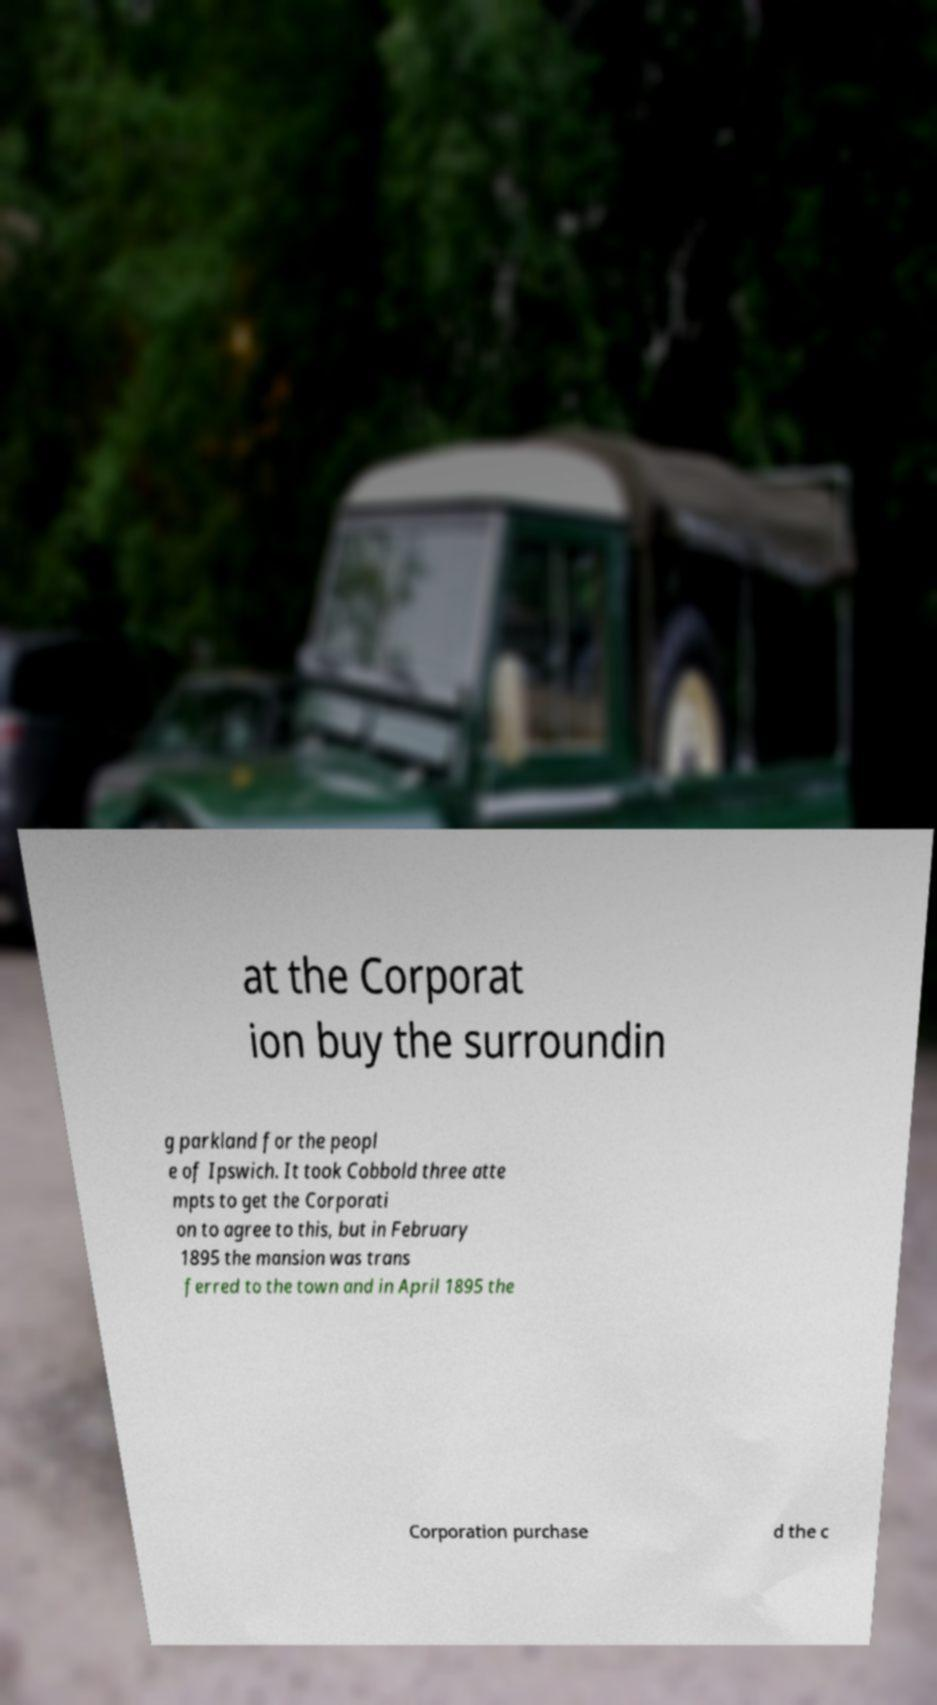Can you read and provide the text displayed in the image?This photo seems to have some interesting text. Can you extract and type it out for me? at the Corporat ion buy the surroundin g parkland for the peopl e of Ipswich. It took Cobbold three atte mpts to get the Corporati on to agree to this, but in February 1895 the mansion was trans ferred to the town and in April 1895 the Corporation purchase d the c 